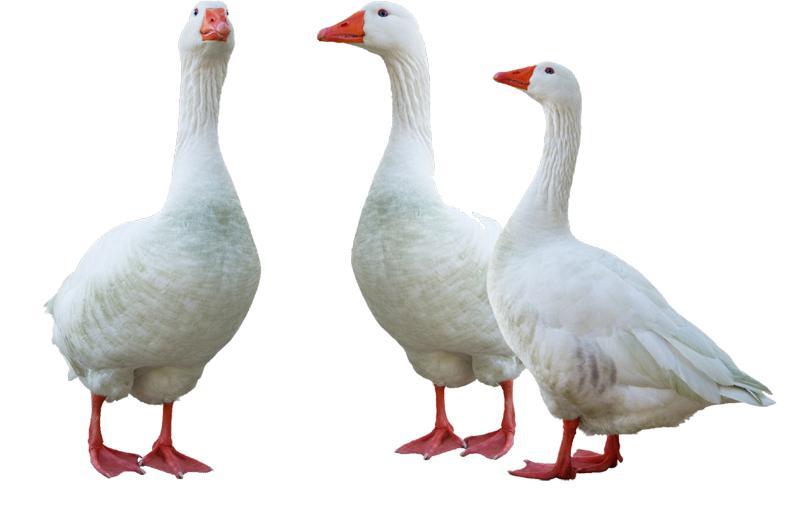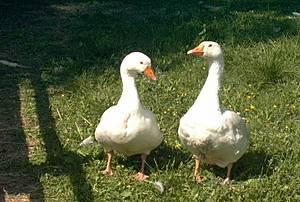The first image is the image on the left, the second image is the image on the right. Evaluate the accuracy of this statement regarding the images: "The right image contains exactly two ducks walking on grass.". Is it true? Answer yes or no. Yes. The first image is the image on the left, the second image is the image on the right. Assess this claim about the two images: "One image contains exactly three solid-white ducks, and the other image contains at least one solid-white duck.". Correct or not? Answer yes or no. Yes. 